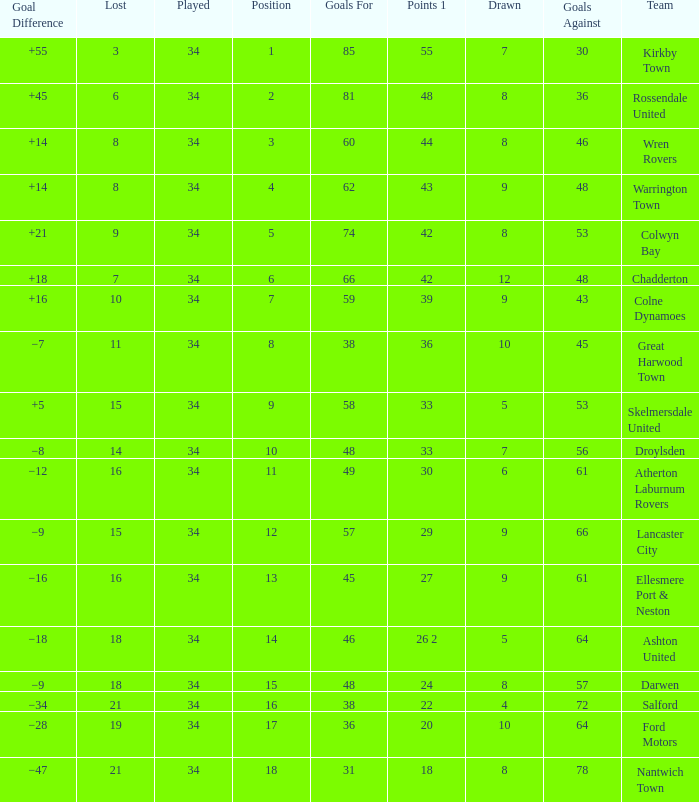What is the smallest number of goals against when 8 games were lost, and the goals for are 60? 46.0. 